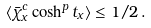Convert formula to latex. <formula><loc_0><loc_0><loc_500><loc_500>\langle \bar { \chi } _ { x } ^ { c } \cosh ^ { p } t _ { x } \rangle \leq 1 / 2 \, .</formula> 